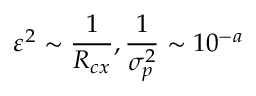<formula> <loc_0><loc_0><loc_500><loc_500>\varepsilon ^ { 2 } \sim \frac { 1 } { R _ { c x } } , \frac { 1 } { \sigma _ { p } ^ { 2 } } \sim 1 0 ^ { - a }</formula> 